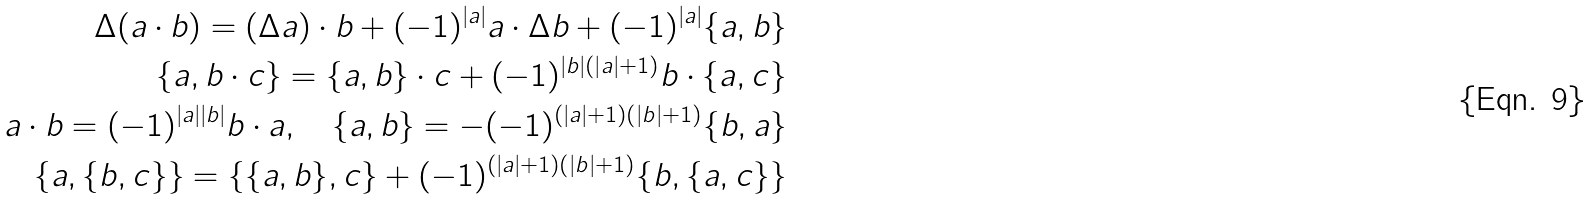Convert formula to latex. <formula><loc_0><loc_0><loc_500><loc_500>\Delta ( a \cdot b ) = ( \Delta a ) \cdot b + ( - 1 ) ^ { | a | } a \cdot \Delta b + ( - 1 ) ^ { | a | } \{ a , b \} \\ \{ a , b \cdot c \} = \{ a , b \} \cdot c + ( - 1 ) ^ { | b | ( | a | + 1 ) } b \cdot \{ a , c \} \\ a \cdot b = ( - 1 ) ^ { | a | | b | } b \cdot a , \quad \{ a , b \} = - ( - 1 ) ^ { ( | a | + 1 ) ( | b | + 1 ) } \{ b , a \} \\ \{ a , \{ b , c \} \} = \{ \{ a , b \} , c \} + ( - 1 ) ^ { ( | a | + 1 ) ( | b | + 1 ) } \{ b , \{ a , c \} \}</formula> 